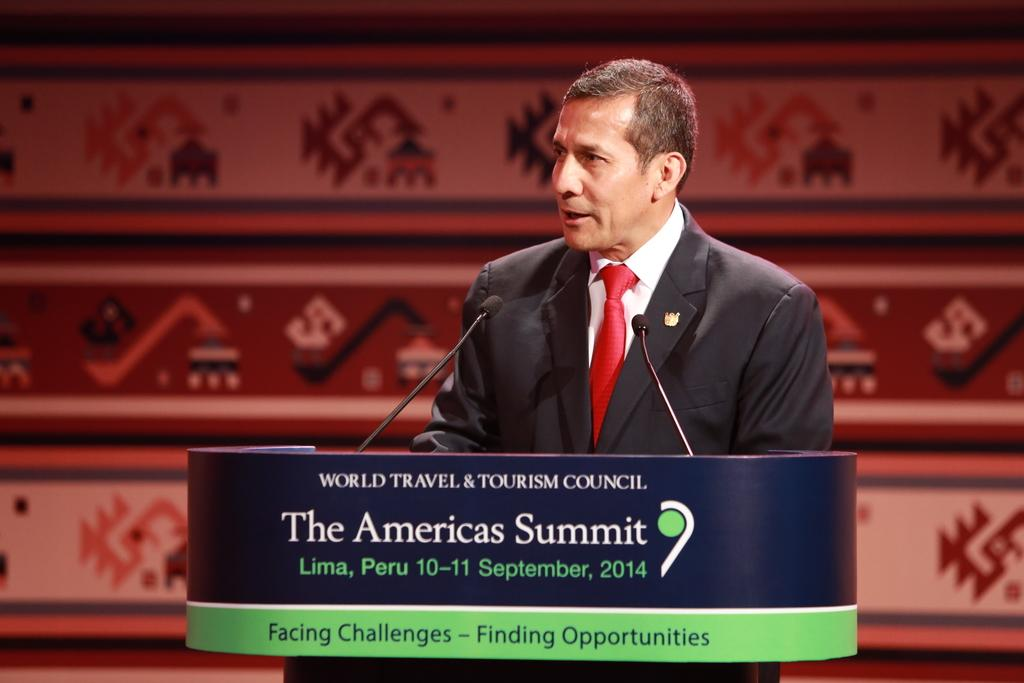Who is the main subject in the image? There is a man in the image. What is the man doing in the image? The man is standing in front of a podium. What can be seen on the podium? There are microphones on the podium, and something is written on it. What type of sea creature is visible on the podium in the image? There is no sea creature present on the podium in the image. What statement is the man making in the image? The image does not provide any information about a statement being made by the man. 